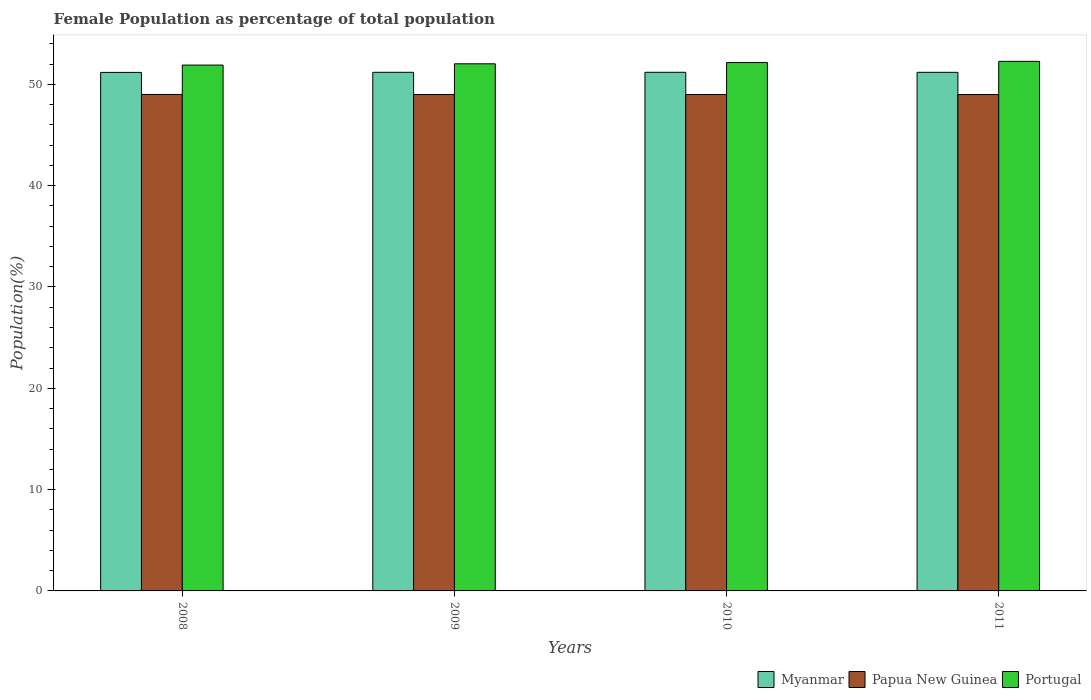How many different coloured bars are there?
Your answer should be compact. 3. How many groups of bars are there?
Make the answer very short. 4. Are the number of bars on each tick of the X-axis equal?
Offer a terse response. Yes. What is the female population in in Myanmar in 2009?
Your answer should be compact. 51.18. Across all years, what is the maximum female population in in Papua New Guinea?
Offer a very short reply. 49. Across all years, what is the minimum female population in in Portugal?
Provide a succinct answer. 51.9. What is the total female population in in Papua New Guinea in the graph?
Offer a very short reply. 195.98. What is the difference between the female population in in Papua New Guinea in 2009 and that in 2011?
Ensure brevity in your answer.  0. What is the difference between the female population in in Portugal in 2011 and the female population in in Papua New Guinea in 2010?
Make the answer very short. 3.27. What is the average female population in in Portugal per year?
Offer a terse response. 52.08. In the year 2008, what is the difference between the female population in in Myanmar and female population in in Portugal?
Make the answer very short. -0.72. In how many years, is the female population in in Papua New Guinea greater than 22 %?
Keep it short and to the point. 4. What is the ratio of the female population in in Portugal in 2008 to that in 2011?
Give a very brief answer. 0.99. Is the female population in in Papua New Guinea in 2008 less than that in 2009?
Your response must be concise. No. What is the difference between the highest and the second highest female population in in Myanmar?
Your answer should be compact. 0. What is the difference between the highest and the lowest female population in in Portugal?
Your response must be concise. 0.37. Is the sum of the female population in in Myanmar in 2009 and 2011 greater than the maximum female population in in Portugal across all years?
Ensure brevity in your answer.  Yes. What does the 1st bar from the right in 2011 represents?
Provide a succinct answer. Portugal. Is it the case that in every year, the sum of the female population in in Portugal and female population in in Myanmar is greater than the female population in in Papua New Guinea?
Make the answer very short. Yes. Are all the bars in the graph horizontal?
Keep it short and to the point. No. How many years are there in the graph?
Make the answer very short. 4. What is the difference between two consecutive major ticks on the Y-axis?
Keep it short and to the point. 10. Are the values on the major ticks of Y-axis written in scientific E-notation?
Your answer should be compact. No. Does the graph contain any zero values?
Give a very brief answer. No. Where does the legend appear in the graph?
Give a very brief answer. Bottom right. How many legend labels are there?
Provide a succinct answer. 3. How are the legend labels stacked?
Make the answer very short. Horizontal. What is the title of the graph?
Give a very brief answer. Female Population as percentage of total population. What is the label or title of the Y-axis?
Your response must be concise. Population(%). What is the Population(%) in Myanmar in 2008?
Provide a succinct answer. 51.18. What is the Population(%) of Papua New Guinea in 2008?
Offer a very short reply. 49. What is the Population(%) of Portugal in 2008?
Your response must be concise. 51.9. What is the Population(%) in Myanmar in 2009?
Make the answer very short. 51.18. What is the Population(%) of Papua New Guinea in 2009?
Ensure brevity in your answer.  49. What is the Population(%) of Portugal in 2009?
Give a very brief answer. 52.02. What is the Population(%) of Myanmar in 2010?
Your answer should be compact. 51.19. What is the Population(%) of Papua New Guinea in 2010?
Your response must be concise. 48.99. What is the Population(%) in Portugal in 2010?
Ensure brevity in your answer.  52.15. What is the Population(%) of Myanmar in 2011?
Your answer should be compact. 51.18. What is the Population(%) of Papua New Guinea in 2011?
Keep it short and to the point. 48.99. What is the Population(%) of Portugal in 2011?
Your response must be concise. 52.27. Across all years, what is the maximum Population(%) of Myanmar?
Your answer should be very brief. 51.19. Across all years, what is the maximum Population(%) of Papua New Guinea?
Your answer should be compact. 49. Across all years, what is the maximum Population(%) of Portugal?
Your response must be concise. 52.27. Across all years, what is the minimum Population(%) of Myanmar?
Ensure brevity in your answer.  51.18. Across all years, what is the minimum Population(%) of Papua New Guinea?
Offer a very short reply. 48.99. Across all years, what is the minimum Population(%) of Portugal?
Your response must be concise. 51.9. What is the total Population(%) in Myanmar in the graph?
Make the answer very short. 204.73. What is the total Population(%) in Papua New Guinea in the graph?
Keep it short and to the point. 195.98. What is the total Population(%) in Portugal in the graph?
Keep it short and to the point. 208.34. What is the difference between the Population(%) in Myanmar in 2008 and that in 2009?
Provide a succinct answer. -0.01. What is the difference between the Population(%) in Papua New Guinea in 2008 and that in 2009?
Keep it short and to the point. 0. What is the difference between the Population(%) in Portugal in 2008 and that in 2009?
Offer a very short reply. -0.13. What is the difference between the Population(%) in Myanmar in 2008 and that in 2010?
Offer a very short reply. -0.01. What is the difference between the Population(%) of Papua New Guinea in 2008 and that in 2010?
Provide a short and direct response. 0.01. What is the difference between the Population(%) of Portugal in 2008 and that in 2010?
Provide a succinct answer. -0.25. What is the difference between the Population(%) of Myanmar in 2008 and that in 2011?
Make the answer very short. -0.01. What is the difference between the Population(%) in Papua New Guinea in 2008 and that in 2011?
Make the answer very short. 0.01. What is the difference between the Population(%) in Portugal in 2008 and that in 2011?
Offer a terse response. -0.37. What is the difference between the Population(%) of Myanmar in 2009 and that in 2010?
Ensure brevity in your answer.  -0. What is the difference between the Population(%) in Papua New Guinea in 2009 and that in 2010?
Make the answer very short. 0. What is the difference between the Population(%) of Portugal in 2009 and that in 2010?
Your answer should be compact. -0.12. What is the difference between the Population(%) of Myanmar in 2009 and that in 2011?
Give a very brief answer. 0. What is the difference between the Population(%) in Papua New Guinea in 2009 and that in 2011?
Offer a terse response. 0. What is the difference between the Population(%) of Portugal in 2009 and that in 2011?
Give a very brief answer. -0.24. What is the difference between the Population(%) of Myanmar in 2010 and that in 2011?
Offer a terse response. 0. What is the difference between the Population(%) of Papua New Guinea in 2010 and that in 2011?
Keep it short and to the point. 0. What is the difference between the Population(%) of Portugal in 2010 and that in 2011?
Offer a terse response. -0.12. What is the difference between the Population(%) in Myanmar in 2008 and the Population(%) in Papua New Guinea in 2009?
Make the answer very short. 2.18. What is the difference between the Population(%) of Myanmar in 2008 and the Population(%) of Portugal in 2009?
Your response must be concise. -0.85. What is the difference between the Population(%) in Papua New Guinea in 2008 and the Population(%) in Portugal in 2009?
Provide a short and direct response. -3.03. What is the difference between the Population(%) of Myanmar in 2008 and the Population(%) of Papua New Guinea in 2010?
Your answer should be compact. 2.18. What is the difference between the Population(%) in Myanmar in 2008 and the Population(%) in Portugal in 2010?
Your answer should be compact. -0.97. What is the difference between the Population(%) in Papua New Guinea in 2008 and the Population(%) in Portugal in 2010?
Provide a short and direct response. -3.15. What is the difference between the Population(%) in Myanmar in 2008 and the Population(%) in Papua New Guinea in 2011?
Provide a short and direct response. 2.19. What is the difference between the Population(%) in Myanmar in 2008 and the Population(%) in Portugal in 2011?
Keep it short and to the point. -1.09. What is the difference between the Population(%) of Papua New Guinea in 2008 and the Population(%) of Portugal in 2011?
Offer a very short reply. -3.27. What is the difference between the Population(%) in Myanmar in 2009 and the Population(%) in Papua New Guinea in 2010?
Your answer should be very brief. 2.19. What is the difference between the Population(%) of Myanmar in 2009 and the Population(%) of Portugal in 2010?
Keep it short and to the point. -0.96. What is the difference between the Population(%) of Papua New Guinea in 2009 and the Population(%) of Portugal in 2010?
Ensure brevity in your answer.  -3.15. What is the difference between the Population(%) in Myanmar in 2009 and the Population(%) in Papua New Guinea in 2011?
Keep it short and to the point. 2.19. What is the difference between the Population(%) in Myanmar in 2009 and the Population(%) in Portugal in 2011?
Provide a succinct answer. -1.08. What is the difference between the Population(%) in Papua New Guinea in 2009 and the Population(%) in Portugal in 2011?
Provide a short and direct response. -3.27. What is the difference between the Population(%) of Myanmar in 2010 and the Population(%) of Papua New Guinea in 2011?
Keep it short and to the point. 2.2. What is the difference between the Population(%) in Myanmar in 2010 and the Population(%) in Portugal in 2011?
Offer a terse response. -1.08. What is the difference between the Population(%) in Papua New Guinea in 2010 and the Population(%) in Portugal in 2011?
Provide a short and direct response. -3.27. What is the average Population(%) in Myanmar per year?
Your answer should be compact. 51.18. What is the average Population(%) in Papua New Guinea per year?
Ensure brevity in your answer.  48.99. What is the average Population(%) in Portugal per year?
Offer a very short reply. 52.08. In the year 2008, what is the difference between the Population(%) in Myanmar and Population(%) in Papua New Guinea?
Keep it short and to the point. 2.18. In the year 2008, what is the difference between the Population(%) of Myanmar and Population(%) of Portugal?
Make the answer very short. -0.72. In the year 2008, what is the difference between the Population(%) of Papua New Guinea and Population(%) of Portugal?
Your answer should be compact. -2.9. In the year 2009, what is the difference between the Population(%) in Myanmar and Population(%) in Papua New Guinea?
Keep it short and to the point. 2.19. In the year 2009, what is the difference between the Population(%) of Myanmar and Population(%) of Portugal?
Provide a succinct answer. -0.84. In the year 2009, what is the difference between the Population(%) of Papua New Guinea and Population(%) of Portugal?
Your answer should be compact. -3.03. In the year 2010, what is the difference between the Population(%) in Myanmar and Population(%) in Papua New Guinea?
Your answer should be very brief. 2.19. In the year 2010, what is the difference between the Population(%) in Myanmar and Population(%) in Portugal?
Your answer should be very brief. -0.96. In the year 2010, what is the difference between the Population(%) in Papua New Guinea and Population(%) in Portugal?
Ensure brevity in your answer.  -3.16. In the year 2011, what is the difference between the Population(%) in Myanmar and Population(%) in Papua New Guinea?
Keep it short and to the point. 2.19. In the year 2011, what is the difference between the Population(%) in Myanmar and Population(%) in Portugal?
Your answer should be compact. -1.08. In the year 2011, what is the difference between the Population(%) of Papua New Guinea and Population(%) of Portugal?
Your response must be concise. -3.28. What is the ratio of the Population(%) in Myanmar in 2008 to that in 2009?
Give a very brief answer. 1. What is the ratio of the Population(%) of Papua New Guinea in 2008 to that in 2009?
Ensure brevity in your answer.  1. What is the ratio of the Population(%) of Portugal in 2008 to that in 2009?
Ensure brevity in your answer.  1. What is the ratio of the Population(%) of Papua New Guinea in 2008 to that in 2010?
Offer a terse response. 1. What is the ratio of the Population(%) in Myanmar in 2008 to that in 2011?
Provide a succinct answer. 1. What is the ratio of the Population(%) of Papua New Guinea in 2008 to that in 2011?
Offer a terse response. 1. What is the ratio of the Population(%) in Papua New Guinea in 2009 to that in 2010?
Your answer should be compact. 1. What is the ratio of the Population(%) in Portugal in 2009 to that in 2010?
Keep it short and to the point. 1. What is the ratio of the Population(%) of Papua New Guinea in 2009 to that in 2011?
Your answer should be very brief. 1. What is the ratio of the Population(%) in Myanmar in 2010 to that in 2011?
Make the answer very short. 1. What is the ratio of the Population(%) in Papua New Guinea in 2010 to that in 2011?
Your answer should be compact. 1. What is the difference between the highest and the second highest Population(%) in Myanmar?
Offer a very short reply. 0. What is the difference between the highest and the second highest Population(%) in Papua New Guinea?
Offer a very short reply. 0. What is the difference between the highest and the second highest Population(%) of Portugal?
Your response must be concise. 0.12. What is the difference between the highest and the lowest Population(%) of Myanmar?
Your answer should be compact. 0.01. What is the difference between the highest and the lowest Population(%) in Papua New Guinea?
Your response must be concise. 0.01. What is the difference between the highest and the lowest Population(%) in Portugal?
Give a very brief answer. 0.37. 